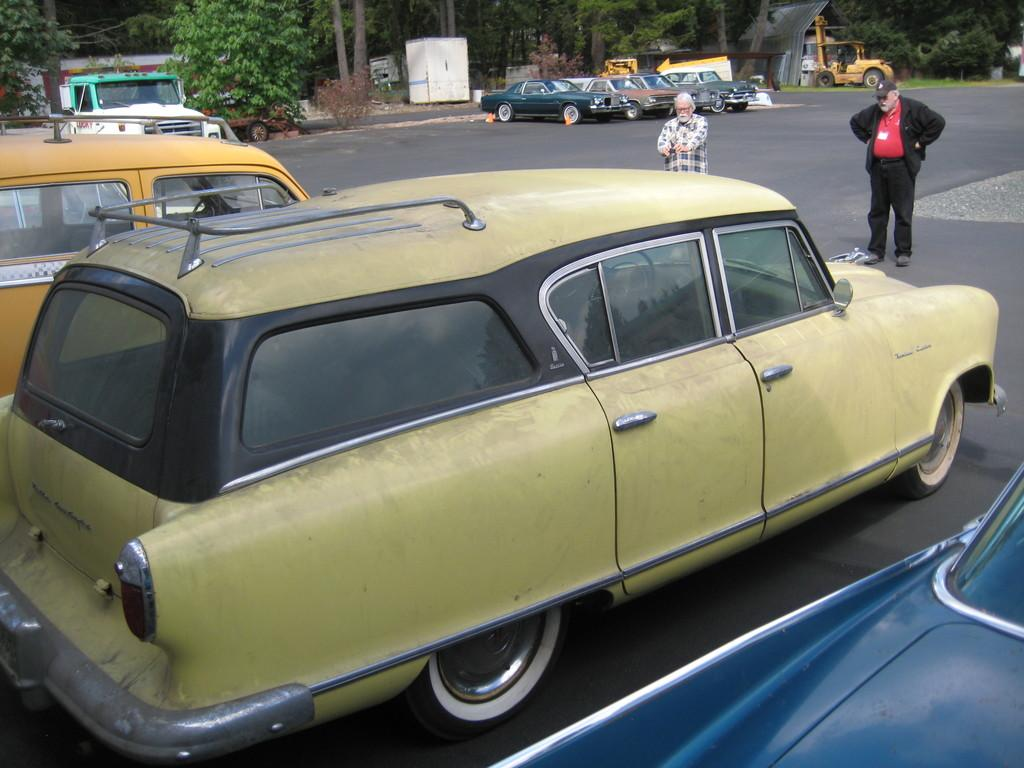What can be seen in the foreground of the image? There are vehicles on the road and two men standing in the foreground of the image. What is visible in the background of the image? There are vehicles and trees in the background of the image. What direction is the cannon facing in the image? There is no cannon present in the image. What idea do the two men in the foreground have in common? We cannot determine any shared ideas between the two men in the image, as their thoughts and intentions are not visible. 